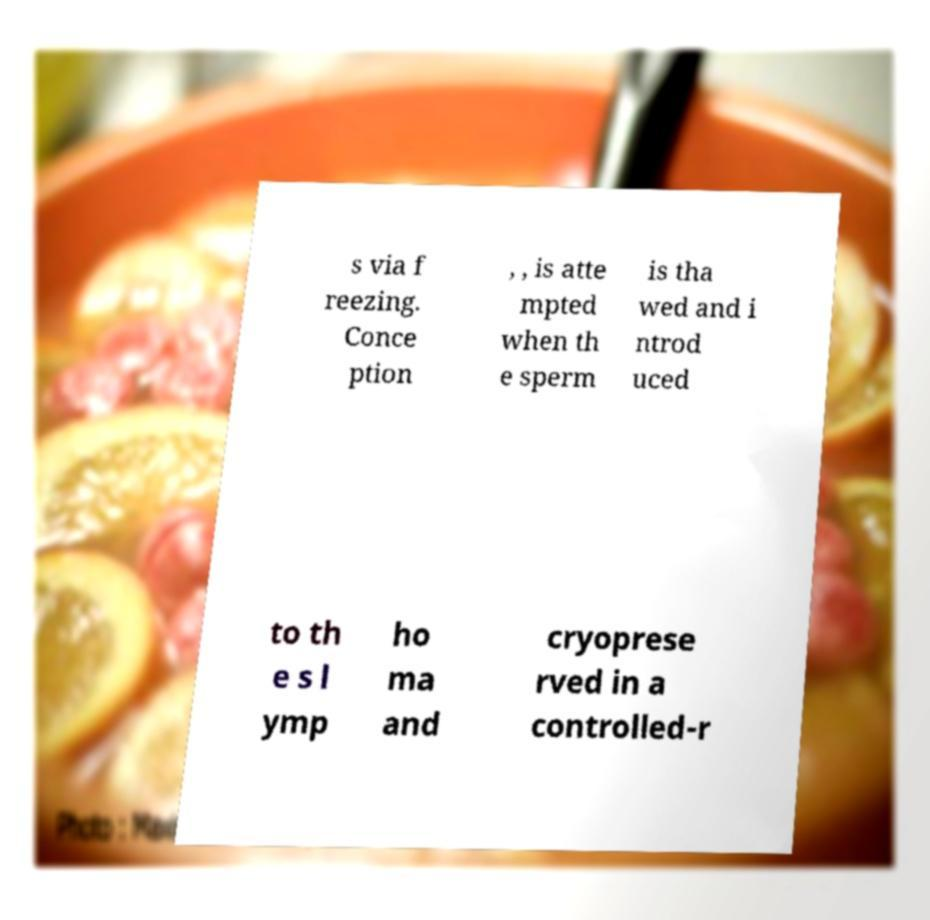Could you extract and type out the text from this image? s via f reezing. Conce ption , , is atte mpted when th e sperm is tha wed and i ntrod uced to th e s l ymp ho ma and cryoprese rved in a controlled-r 